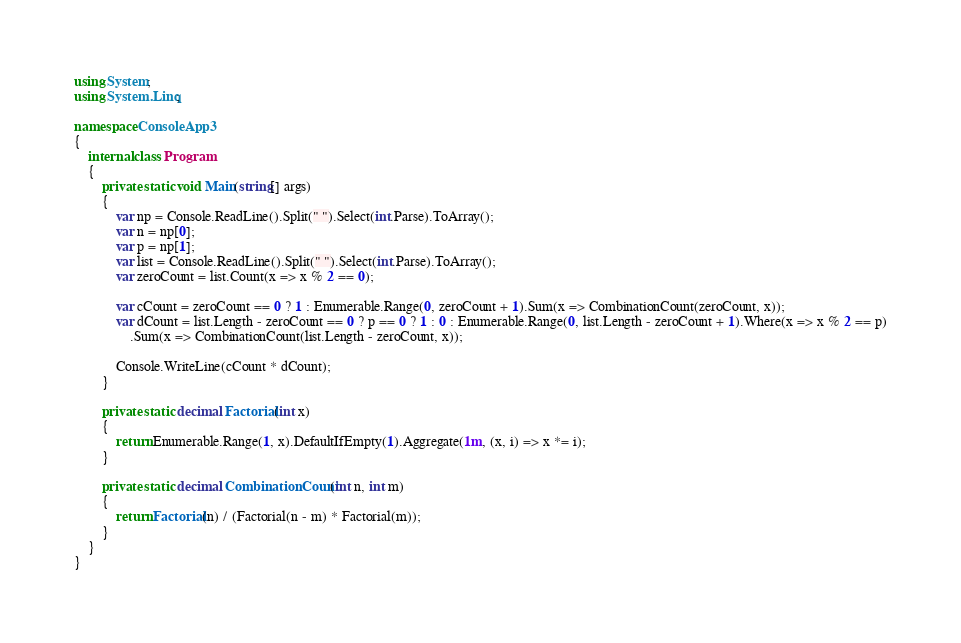<code> <loc_0><loc_0><loc_500><loc_500><_C#_>using System;
using System.Linq;

namespace ConsoleApp3
{
    internal class Program
    {
        private static void Main(string[] args)
        {
            var np = Console.ReadLine().Split(" ").Select(int.Parse).ToArray();
            var n = np[0];
            var p = np[1];
            var list = Console.ReadLine().Split(" ").Select(int.Parse).ToArray();
            var zeroCount = list.Count(x => x % 2 == 0);

            var cCount = zeroCount == 0 ? 1 : Enumerable.Range(0, zeroCount + 1).Sum(x => CombinationCount(zeroCount, x));
            var dCount = list.Length - zeroCount == 0 ? p == 0 ? 1 : 0 : Enumerable.Range(0, list.Length - zeroCount + 1).Where(x => x % 2 == p)
                .Sum(x => CombinationCount(list.Length - zeroCount, x));

            Console.WriteLine(cCount * dCount);
        }

        private static decimal Factorial(int x)
        {
            return Enumerable.Range(1, x).DefaultIfEmpty(1).Aggregate(1m, (x, i) => x *= i);
        }

        private static decimal CombinationCount(int n, int m)
        {
            return Factorial(n) / (Factorial(n - m) * Factorial(m));
        }
    }
}</code> 